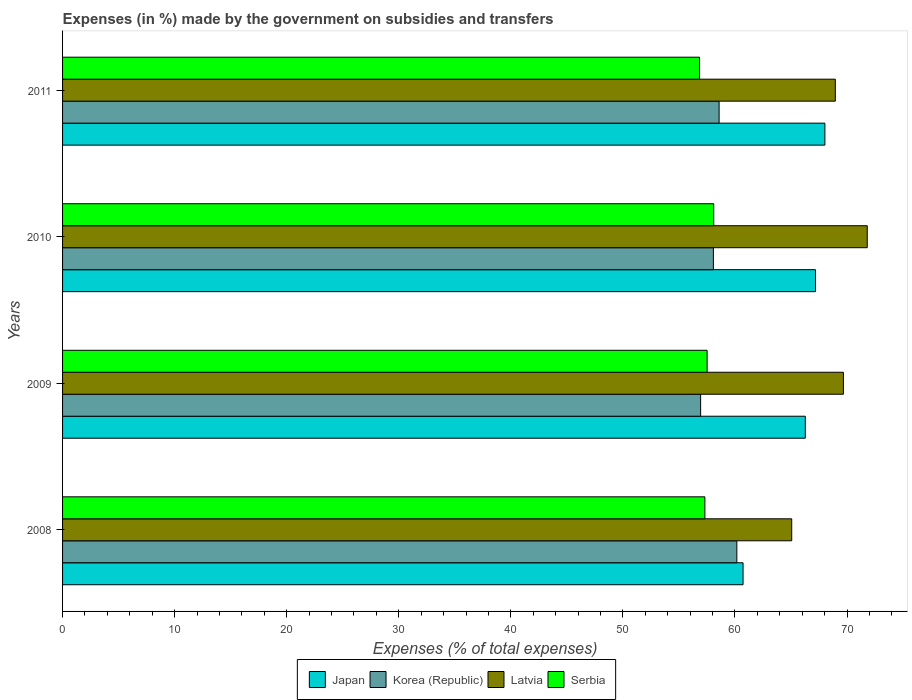How many different coloured bars are there?
Ensure brevity in your answer.  4. How many groups of bars are there?
Provide a succinct answer. 4. Are the number of bars on each tick of the Y-axis equal?
Make the answer very short. Yes. How many bars are there on the 2nd tick from the top?
Provide a short and direct response. 4. In how many cases, is the number of bars for a given year not equal to the number of legend labels?
Offer a terse response. 0. What is the percentage of expenses made by the government on subsidies and transfers in Latvia in 2008?
Provide a succinct answer. 65.07. Across all years, what is the maximum percentage of expenses made by the government on subsidies and transfers in Latvia?
Offer a terse response. 71.81. Across all years, what is the minimum percentage of expenses made by the government on subsidies and transfers in Latvia?
Offer a terse response. 65.07. In which year was the percentage of expenses made by the government on subsidies and transfers in Japan maximum?
Your answer should be compact. 2011. What is the total percentage of expenses made by the government on subsidies and transfers in Latvia in the graph?
Offer a terse response. 275.51. What is the difference between the percentage of expenses made by the government on subsidies and transfers in Latvia in 2009 and that in 2011?
Offer a very short reply. 0.72. What is the difference between the percentage of expenses made by the government on subsidies and transfers in Serbia in 2010 and the percentage of expenses made by the government on subsidies and transfers in Korea (Republic) in 2009?
Provide a short and direct response. 1.17. What is the average percentage of expenses made by the government on subsidies and transfers in Korea (Republic) per year?
Ensure brevity in your answer.  58.44. In the year 2011, what is the difference between the percentage of expenses made by the government on subsidies and transfers in Latvia and percentage of expenses made by the government on subsidies and transfers in Serbia?
Your response must be concise. 12.12. What is the ratio of the percentage of expenses made by the government on subsidies and transfers in Korea (Republic) in 2008 to that in 2009?
Provide a short and direct response. 1.06. Is the difference between the percentage of expenses made by the government on subsidies and transfers in Latvia in 2010 and 2011 greater than the difference between the percentage of expenses made by the government on subsidies and transfers in Serbia in 2010 and 2011?
Offer a very short reply. Yes. What is the difference between the highest and the second highest percentage of expenses made by the government on subsidies and transfers in Korea (Republic)?
Your answer should be compact. 1.58. What is the difference between the highest and the lowest percentage of expenses made by the government on subsidies and transfers in Japan?
Your answer should be very brief. 7.3. Is the sum of the percentage of expenses made by the government on subsidies and transfers in Serbia in 2010 and 2011 greater than the maximum percentage of expenses made by the government on subsidies and transfers in Latvia across all years?
Make the answer very short. Yes. What does the 1st bar from the top in 2011 represents?
Provide a succinct answer. Serbia. Is it the case that in every year, the sum of the percentage of expenses made by the government on subsidies and transfers in Latvia and percentage of expenses made by the government on subsidies and transfers in Japan is greater than the percentage of expenses made by the government on subsidies and transfers in Korea (Republic)?
Ensure brevity in your answer.  Yes. How many bars are there?
Give a very brief answer. 16. Are the values on the major ticks of X-axis written in scientific E-notation?
Keep it short and to the point. No. Does the graph contain any zero values?
Your answer should be compact. No. How many legend labels are there?
Make the answer very short. 4. How are the legend labels stacked?
Your response must be concise. Horizontal. What is the title of the graph?
Keep it short and to the point. Expenses (in %) made by the government on subsidies and transfers. What is the label or title of the X-axis?
Provide a succinct answer. Expenses (% of total expenses). What is the label or title of the Y-axis?
Ensure brevity in your answer.  Years. What is the Expenses (% of total expenses) of Japan in 2008?
Offer a very short reply. 60.72. What is the Expenses (% of total expenses) of Korea (Republic) in 2008?
Keep it short and to the point. 60.17. What is the Expenses (% of total expenses) of Latvia in 2008?
Your response must be concise. 65.07. What is the Expenses (% of total expenses) in Serbia in 2008?
Ensure brevity in your answer.  57.32. What is the Expenses (% of total expenses) of Japan in 2009?
Provide a succinct answer. 66.28. What is the Expenses (% of total expenses) in Korea (Republic) in 2009?
Your answer should be compact. 56.94. What is the Expenses (% of total expenses) of Latvia in 2009?
Provide a succinct answer. 69.68. What is the Expenses (% of total expenses) in Serbia in 2009?
Offer a very short reply. 57.52. What is the Expenses (% of total expenses) of Japan in 2010?
Your response must be concise. 67.19. What is the Expenses (% of total expenses) of Korea (Republic) in 2010?
Keep it short and to the point. 58.08. What is the Expenses (% of total expenses) in Latvia in 2010?
Ensure brevity in your answer.  71.81. What is the Expenses (% of total expenses) of Serbia in 2010?
Your response must be concise. 58.11. What is the Expenses (% of total expenses) in Japan in 2011?
Your answer should be very brief. 68.03. What is the Expenses (% of total expenses) of Korea (Republic) in 2011?
Give a very brief answer. 58.59. What is the Expenses (% of total expenses) in Latvia in 2011?
Provide a succinct answer. 68.96. What is the Expenses (% of total expenses) of Serbia in 2011?
Your answer should be very brief. 56.84. Across all years, what is the maximum Expenses (% of total expenses) of Japan?
Your response must be concise. 68.03. Across all years, what is the maximum Expenses (% of total expenses) of Korea (Republic)?
Your answer should be compact. 60.17. Across all years, what is the maximum Expenses (% of total expenses) in Latvia?
Offer a terse response. 71.81. Across all years, what is the maximum Expenses (% of total expenses) in Serbia?
Offer a terse response. 58.11. Across all years, what is the minimum Expenses (% of total expenses) of Japan?
Provide a succinct answer. 60.72. Across all years, what is the minimum Expenses (% of total expenses) in Korea (Republic)?
Provide a short and direct response. 56.94. Across all years, what is the minimum Expenses (% of total expenses) of Latvia?
Make the answer very short. 65.07. Across all years, what is the minimum Expenses (% of total expenses) in Serbia?
Provide a short and direct response. 56.84. What is the total Expenses (% of total expenses) of Japan in the graph?
Make the answer very short. 262.22. What is the total Expenses (% of total expenses) in Korea (Republic) in the graph?
Offer a terse response. 233.77. What is the total Expenses (% of total expenses) in Latvia in the graph?
Provide a short and direct response. 275.51. What is the total Expenses (% of total expenses) in Serbia in the graph?
Make the answer very short. 229.78. What is the difference between the Expenses (% of total expenses) in Japan in 2008 and that in 2009?
Your response must be concise. -5.56. What is the difference between the Expenses (% of total expenses) of Korea (Republic) in 2008 and that in 2009?
Your answer should be compact. 3.23. What is the difference between the Expenses (% of total expenses) of Latvia in 2008 and that in 2009?
Give a very brief answer. -4.61. What is the difference between the Expenses (% of total expenses) in Serbia in 2008 and that in 2009?
Provide a succinct answer. -0.2. What is the difference between the Expenses (% of total expenses) of Japan in 2008 and that in 2010?
Offer a very short reply. -6.46. What is the difference between the Expenses (% of total expenses) of Korea (Republic) in 2008 and that in 2010?
Keep it short and to the point. 2.09. What is the difference between the Expenses (% of total expenses) of Latvia in 2008 and that in 2010?
Ensure brevity in your answer.  -6.74. What is the difference between the Expenses (% of total expenses) in Serbia in 2008 and that in 2010?
Make the answer very short. -0.79. What is the difference between the Expenses (% of total expenses) in Japan in 2008 and that in 2011?
Ensure brevity in your answer.  -7.3. What is the difference between the Expenses (% of total expenses) of Korea (Republic) in 2008 and that in 2011?
Provide a short and direct response. 1.58. What is the difference between the Expenses (% of total expenses) of Latvia in 2008 and that in 2011?
Make the answer very short. -3.89. What is the difference between the Expenses (% of total expenses) in Serbia in 2008 and that in 2011?
Your answer should be very brief. 0.48. What is the difference between the Expenses (% of total expenses) of Japan in 2009 and that in 2010?
Give a very brief answer. -0.91. What is the difference between the Expenses (% of total expenses) of Korea (Republic) in 2009 and that in 2010?
Provide a succinct answer. -1.14. What is the difference between the Expenses (% of total expenses) of Latvia in 2009 and that in 2010?
Offer a terse response. -2.13. What is the difference between the Expenses (% of total expenses) in Serbia in 2009 and that in 2010?
Give a very brief answer. -0.59. What is the difference between the Expenses (% of total expenses) of Japan in 2009 and that in 2011?
Your answer should be very brief. -1.75. What is the difference between the Expenses (% of total expenses) of Korea (Republic) in 2009 and that in 2011?
Make the answer very short. -1.65. What is the difference between the Expenses (% of total expenses) in Latvia in 2009 and that in 2011?
Give a very brief answer. 0.72. What is the difference between the Expenses (% of total expenses) of Serbia in 2009 and that in 2011?
Give a very brief answer. 0.68. What is the difference between the Expenses (% of total expenses) of Japan in 2010 and that in 2011?
Ensure brevity in your answer.  -0.84. What is the difference between the Expenses (% of total expenses) in Korea (Republic) in 2010 and that in 2011?
Provide a succinct answer. -0.51. What is the difference between the Expenses (% of total expenses) in Latvia in 2010 and that in 2011?
Ensure brevity in your answer.  2.85. What is the difference between the Expenses (% of total expenses) of Serbia in 2010 and that in 2011?
Your answer should be compact. 1.27. What is the difference between the Expenses (% of total expenses) of Japan in 2008 and the Expenses (% of total expenses) of Korea (Republic) in 2009?
Offer a terse response. 3.79. What is the difference between the Expenses (% of total expenses) of Japan in 2008 and the Expenses (% of total expenses) of Latvia in 2009?
Keep it short and to the point. -8.96. What is the difference between the Expenses (% of total expenses) of Japan in 2008 and the Expenses (% of total expenses) of Serbia in 2009?
Your answer should be very brief. 3.21. What is the difference between the Expenses (% of total expenses) in Korea (Republic) in 2008 and the Expenses (% of total expenses) in Latvia in 2009?
Your response must be concise. -9.51. What is the difference between the Expenses (% of total expenses) in Korea (Republic) in 2008 and the Expenses (% of total expenses) in Serbia in 2009?
Offer a terse response. 2.65. What is the difference between the Expenses (% of total expenses) of Latvia in 2008 and the Expenses (% of total expenses) of Serbia in 2009?
Offer a terse response. 7.55. What is the difference between the Expenses (% of total expenses) of Japan in 2008 and the Expenses (% of total expenses) of Korea (Republic) in 2010?
Ensure brevity in your answer.  2.65. What is the difference between the Expenses (% of total expenses) in Japan in 2008 and the Expenses (% of total expenses) in Latvia in 2010?
Ensure brevity in your answer.  -11.08. What is the difference between the Expenses (% of total expenses) in Japan in 2008 and the Expenses (% of total expenses) in Serbia in 2010?
Your answer should be very brief. 2.62. What is the difference between the Expenses (% of total expenses) of Korea (Republic) in 2008 and the Expenses (% of total expenses) of Latvia in 2010?
Your response must be concise. -11.64. What is the difference between the Expenses (% of total expenses) in Korea (Republic) in 2008 and the Expenses (% of total expenses) in Serbia in 2010?
Keep it short and to the point. 2.06. What is the difference between the Expenses (% of total expenses) in Latvia in 2008 and the Expenses (% of total expenses) in Serbia in 2010?
Offer a terse response. 6.96. What is the difference between the Expenses (% of total expenses) of Japan in 2008 and the Expenses (% of total expenses) of Korea (Republic) in 2011?
Your answer should be compact. 2.14. What is the difference between the Expenses (% of total expenses) of Japan in 2008 and the Expenses (% of total expenses) of Latvia in 2011?
Your answer should be very brief. -8.23. What is the difference between the Expenses (% of total expenses) of Japan in 2008 and the Expenses (% of total expenses) of Serbia in 2011?
Keep it short and to the point. 3.88. What is the difference between the Expenses (% of total expenses) in Korea (Republic) in 2008 and the Expenses (% of total expenses) in Latvia in 2011?
Offer a terse response. -8.79. What is the difference between the Expenses (% of total expenses) in Korea (Republic) in 2008 and the Expenses (% of total expenses) in Serbia in 2011?
Ensure brevity in your answer.  3.33. What is the difference between the Expenses (% of total expenses) of Latvia in 2008 and the Expenses (% of total expenses) of Serbia in 2011?
Offer a terse response. 8.23. What is the difference between the Expenses (% of total expenses) of Japan in 2009 and the Expenses (% of total expenses) of Korea (Republic) in 2010?
Your response must be concise. 8.2. What is the difference between the Expenses (% of total expenses) in Japan in 2009 and the Expenses (% of total expenses) in Latvia in 2010?
Your answer should be very brief. -5.53. What is the difference between the Expenses (% of total expenses) of Japan in 2009 and the Expenses (% of total expenses) of Serbia in 2010?
Your response must be concise. 8.17. What is the difference between the Expenses (% of total expenses) in Korea (Republic) in 2009 and the Expenses (% of total expenses) in Latvia in 2010?
Make the answer very short. -14.87. What is the difference between the Expenses (% of total expenses) in Korea (Republic) in 2009 and the Expenses (% of total expenses) in Serbia in 2010?
Ensure brevity in your answer.  -1.17. What is the difference between the Expenses (% of total expenses) of Latvia in 2009 and the Expenses (% of total expenses) of Serbia in 2010?
Provide a short and direct response. 11.57. What is the difference between the Expenses (% of total expenses) of Japan in 2009 and the Expenses (% of total expenses) of Korea (Republic) in 2011?
Provide a succinct answer. 7.69. What is the difference between the Expenses (% of total expenses) of Japan in 2009 and the Expenses (% of total expenses) of Latvia in 2011?
Provide a succinct answer. -2.68. What is the difference between the Expenses (% of total expenses) in Japan in 2009 and the Expenses (% of total expenses) in Serbia in 2011?
Offer a terse response. 9.44. What is the difference between the Expenses (% of total expenses) in Korea (Republic) in 2009 and the Expenses (% of total expenses) in Latvia in 2011?
Offer a very short reply. -12.02. What is the difference between the Expenses (% of total expenses) of Korea (Republic) in 2009 and the Expenses (% of total expenses) of Serbia in 2011?
Provide a short and direct response. 0.1. What is the difference between the Expenses (% of total expenses) in Latvia in 2009 and the Expenses (% of total expenses) in Serbia in 2011?
Provide a succinct answer. 12.84. What is the difference between the Expenses (% of total expenses) in Japan in 2010 and the Expenses (% of total expenses) in Korea (Republic) in 2011?
Keep it short and to the point. 8.6. What is the difference between the Expenses (% of total expenses) of Japan in 2010 and the Expenses (% of total expenses) of Latvia in 2011?
Your response must be concise. -1.77. What is the difference between the Expenses (% of total expenses) in Japan in 2010 and the Expenses (% of total expenses) in Serbia in 2011?
Offer a very short reply. 10.35. What is the difference between the Expenses (% of total expenses) in Korea (Republic) in 2010 and the Expenses (% of total expenses) in Latvia in 2011?
Make the answer very short. -10.88. What is the difference between the Expenses (% of total expenses) in Korea (Republic) in 2010 and the Expenses (% of total expenses) in Serbia in 2011?
Your answer should be compact. 1.24. What is the difference between the Expenses (% of total expenses) in Latvia in 2010 and the Expenses (% of total expenses) in Serbia in 2011?
Make the answer very short. 14.97. What is the average Expenses (% of total expenses) in Japan per year?
Give a very brief answer. 65.55. What is the average Expenses (% of total expenses) in Korea (Republic) per year?
Ensure brevity in your answer.  58.44. What is the average Expenses (% of total expenses) in Latvia per year?
Make the answer very short. 68.88. What is the average Expenses (% of total expenses) in Serbia per year?
Provide a short and direct response. 57.44. In the year 2008, what is the difference between the Expenses (% of total expenses) in Japan and Expenses (% of total expenses) in Korea (Republic)?
Provide a short and direct response. 0.55. In the year 2008, what is the difference between the Expenses (% of total expenses) in Japan and Expenses (% of total expenses) in Latvia?
Provide a short and direct response. -4.34. In the year 2008, what is the difference between the Expenses (% of total expenses) of Japan and Expenses (% of total expenses) of Serbia?
Your answer should be very brief. 3.41. In the year 2008, what is the difference between the Expenses (% of total expenses) of Korea (Republic) and Expenses (% of total expenses) of Latvia?
Offer a very short reply. -4.9. In the year 2008, what is the difference between the Expenses (% of total expenses) in Korea (Republic) and Expenses (% of total expenses) in Serbia?
Keep it short and to the point. 2.85. In the year 2008, what is the difference between the Expenses (% of total expenses) in Latvia and Expenses (% of total expenses) in Serbia?
Your answer should be compact. 7.75. In the year 2009, what is the difference between the Expenses (% of total expenses) in Japan and Expenses (% of total expenses) in Korea (Republic)?
Provide a succinct answer. 9.34. In the year 2009, what is the difference between the Expenses (% of total expenses) of Japan and Expenses (% of total expenses) of Latvia?
Give a very brief answer. -3.4. In the year 2009, what is the difference between the Expenses (% of total expenses) in Japan and Expenses (% of total expenses) in Serbia?
Provide a short and direct response. 8.76. In the year 2009, what is the difference between the Expenses (% of total expenses) in Korea (Republic) and Expenses (% of total expenses) in Latvia?
Your response must be concise. -12.74. In the year 2009, what is the difference between the Expenses (% of total expenses) in Korea (Republic) and Expenses (% of total expenses) in Serbia?
Make the answer very short. -0.58. In the year 2009, what is the difference between the Expenses (% of total expenses) of Latvia and Expenses (% of total expenses) of Serbia?
Give a very brief answer. 12.16. In the year 2010, what is the difference between the Expenses (% of total expenses) in Japan and Expenses (% of total expenses) in Korea (Republic)?
Offer a terse response. 9.11. In the year 2010, what is the difference between the Expenses (% of total expenses) of Japan and Expenses (% of total expenses) of Latvia?
Ensure brevity in your answer.  -4.62. In the year 2010, what is the difference between the Expenses (% of total expenses) in Japan and Expenses (% of total expenses) in Serbia?
Give a very brief answer. 9.08. In the year 2010, what is the difference between the Expenses (% of total expenses) of Korea (Republic) and Expenses (% of total expenses) of Latvia?
Give a very brief answer. -13.73. In the year 2010, what is the difference between the Expenses (% of total expenses) of Korea (Republic) and Expenses (% of total expenses) of Serbia?
Provide a short and direct response. -0.03. In the year 2010, what is the difference between the Expenses (% of total expenses) in Latvia and Expenses (% of total expenses) in Serbia?
Your answer should be compact. 13.7. In the year 2011, what is the difference between the Expenses (% of total expenses) of Japan and Expenses (% of total expenses) of Korea (Republic)?
Provide a short and direct response. 9.44. In the year 2011, what is the difference between the Expenses (% of total expenses) of Japan and Expenses (% of total expenses) of Latvia?
Give a very brief answer. -0.93. In the year 2011, what is the difference between the Expenses (% of total expenses) of Japan and Expenses (% of total expenses) of Serbia?
Your answer should be very brief. 11.19. In the year 2011, what is the difference between the Expenses (% of total expenses) of Korea (Republic) and Expenses (% of total expenses) of Latvia?
Provide a succinct answer. -10.37. In the year 2011, what is the difference between the Expenses (% of total expenses) of Korea (Republic) and Expenses (% of total expenses) of Serbia?
Provide a short and direct response. 1.75. In the year 2011, what is the difference between the Expenses (% of total expenses) of Latvia and Expenses (% of total expenses) of Serbia?
Your answer should be compact. 12.12. What is the ratio of the Expenses (% of total expenses) in Japan in 2008 to that in 2009?
Provide a succinct answer. 0.92. What is the ratio of the Expenses (% of total expenses) in Korea (Republic) in 2008 to that in 2009?
Provide a succinct answer. 1.06. What is the ratio of the Expenses (% of total expenses) in Latvia in 2008 to that in 2009?
Keep it short and to the point. 0.93. What is the ratio of the Expenses (% of total expenses) of Japan in 2008 to that in 2010?
Offer a very short reply. 0.9. What is the ratio of the Expenses (% of total expenses) of Korea (Republic) in 2008 to that in 2010?
Give a very brief answer. 1.04. What is the ratio of the Expenses (% of total expenses) of Latvia in 2008 to that in 2010?
Give a very brief answer. 0.91. What is the ratio of the Expenses (% of total expenses) of Serbia in 2008 to that in 2010?
Offer a terse response. 0.99. What is the ratio of the Expenses (% of total expenses) in Japan in 2008 to that in 2011?
Ensure brevity in your answer.  0.89. What is the ratio of the Expenses (% of total expenses) in Korea (Republic) in 2008 to that in 2011?
Provide a short and direct response. 1.03. What is the ratio of the Expenses (% of total expenses) in Latvia in 2008 to that in 2011?
Offer a very short reply. 0.94. What is the ratio of the Expenses (% of total expenses) in Serbia in 2008 to that in 2011?
Give a very brief answer. 1.01. What is the ratio of the Expenses (% of total expenses) in Japan in 2009 to that in 2010?
Your answer should be very brief. 0.99. What is the ratio of the Expenses (% of total expenses) of Korea (Republic) in 2009 to that in 2010?
Offer a terse response. 0.98. What is the ratio of the Expenses (% of total expenses) in Latvia in 2009 to that in 2010?
Your response must be concise. 0.97. What is the ratio of the Expenses (% of total expenses) in Serbia in 2009 to that in 2010?
Your answer should be compact. 0.99. What is the ratio of the Expenses (% of total expenses) in Japan in 2009 to that in 2011?
Keep it short and to the point. 0.97. What is the ratio of the Expenses (% of total expenses) of Korea (Republic) in 2009 to that in 2011?
Give a very brief answer. 0.97. What is the ratio of the Expenses (% of total expenses) in Latvia in 2009 to that in 2011?
Make the answer very short. 1.01. What is the ratio of the Expenses (% of total expenses) in Serbia in 2009 to that in 2011?
Your answer should be compact. 1.01. What is the ratio of the Expenses (% of total expenses) of Japan in 2010 to that in 2011?
Provide a short and direct response. 0.99. What is the ratio of the Expenses (% of total expenses) in Korea (Republic) in 2010 to that in 2011?
Provide a succinct answer. 0.99. What is the ratio of the Expenses (% of total expenses) in Latvia in 2010 to that in 2011?
Keep it short and to the point. 1.04. What is the ratio of the Expenses (% of total expenses) of Serbia in 2010 to that in 2011?
Make the answer very short. 1.02. What is the difference between the highest and the second highest Expenses (% of total expenses) of Japan?
Make the answer very short. 0.84. What is the difference between the highest and the second highest Expenses (% of total expenses) of Korea (Republic)?
Provide a succinct answer. 1.58. What is the difference between the highest and the second highest Expenses (% of total expenses) in Latvia?
Your answer should be compact. 2.13. What is the difference between the highest and the second highest Expenses (% of total expenses) in Serbia?
Ensure brevity in your answer.  0.59. What is the difference between the highest and the lowest Expenses (% of total expenses) of Japan?
Give a very brief answer. 7.3. What is the difference between the highest and the lowest Expenses (% of total expenses) in Korea (Republic)?
Ensure brevity in your answer.  3.23. What is the difference between the highest and the lowest Expenses (% of total expenses) of Latvia?
Your answer should be very brief. 6.74. What is the difference between the highest and the lowest Expenses (% of total expenses) in Serbia?
Give a very brief answer. 1.27. 